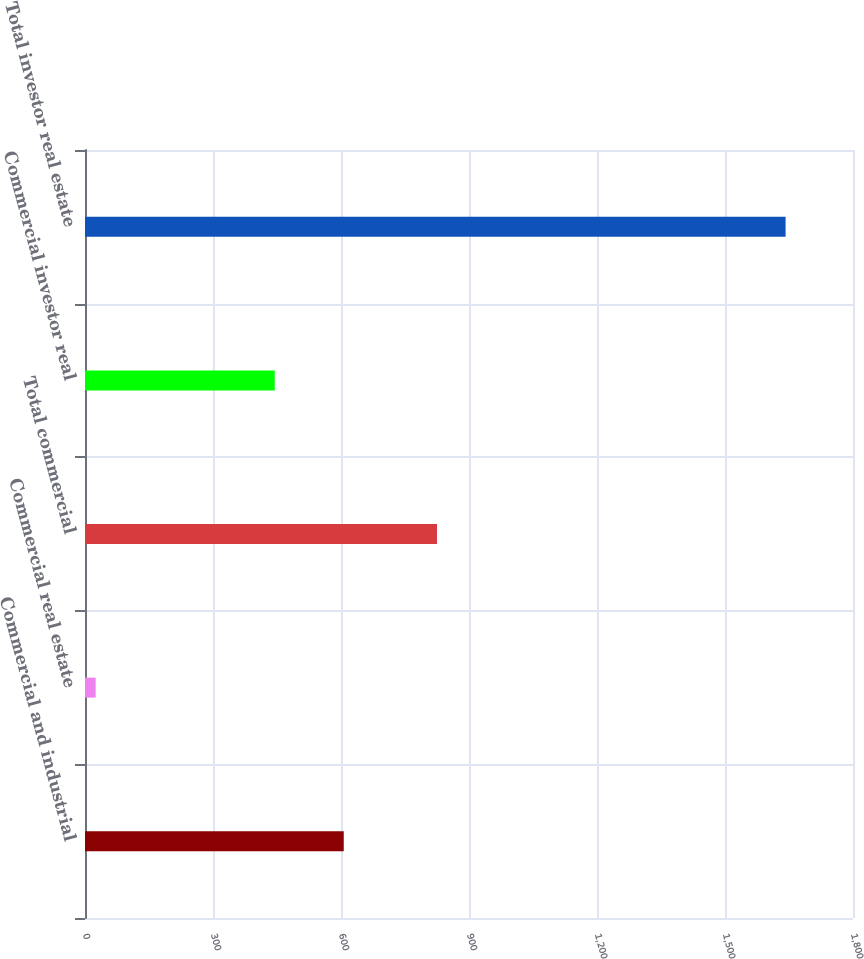Convert chart to OTSL. <chart><loc_0><loc_0><loc_500><loc_500><bar_chart><fcel>Commercial and industrial<fcel>Commercial real estate<fcel>Total commercial<fcel>Commercial investor real<fcel>Total investor real estate<nl><fcel>606.4<fcel>25<fcel>825<fcel>444.7<fcel>1642<nl></chart> 